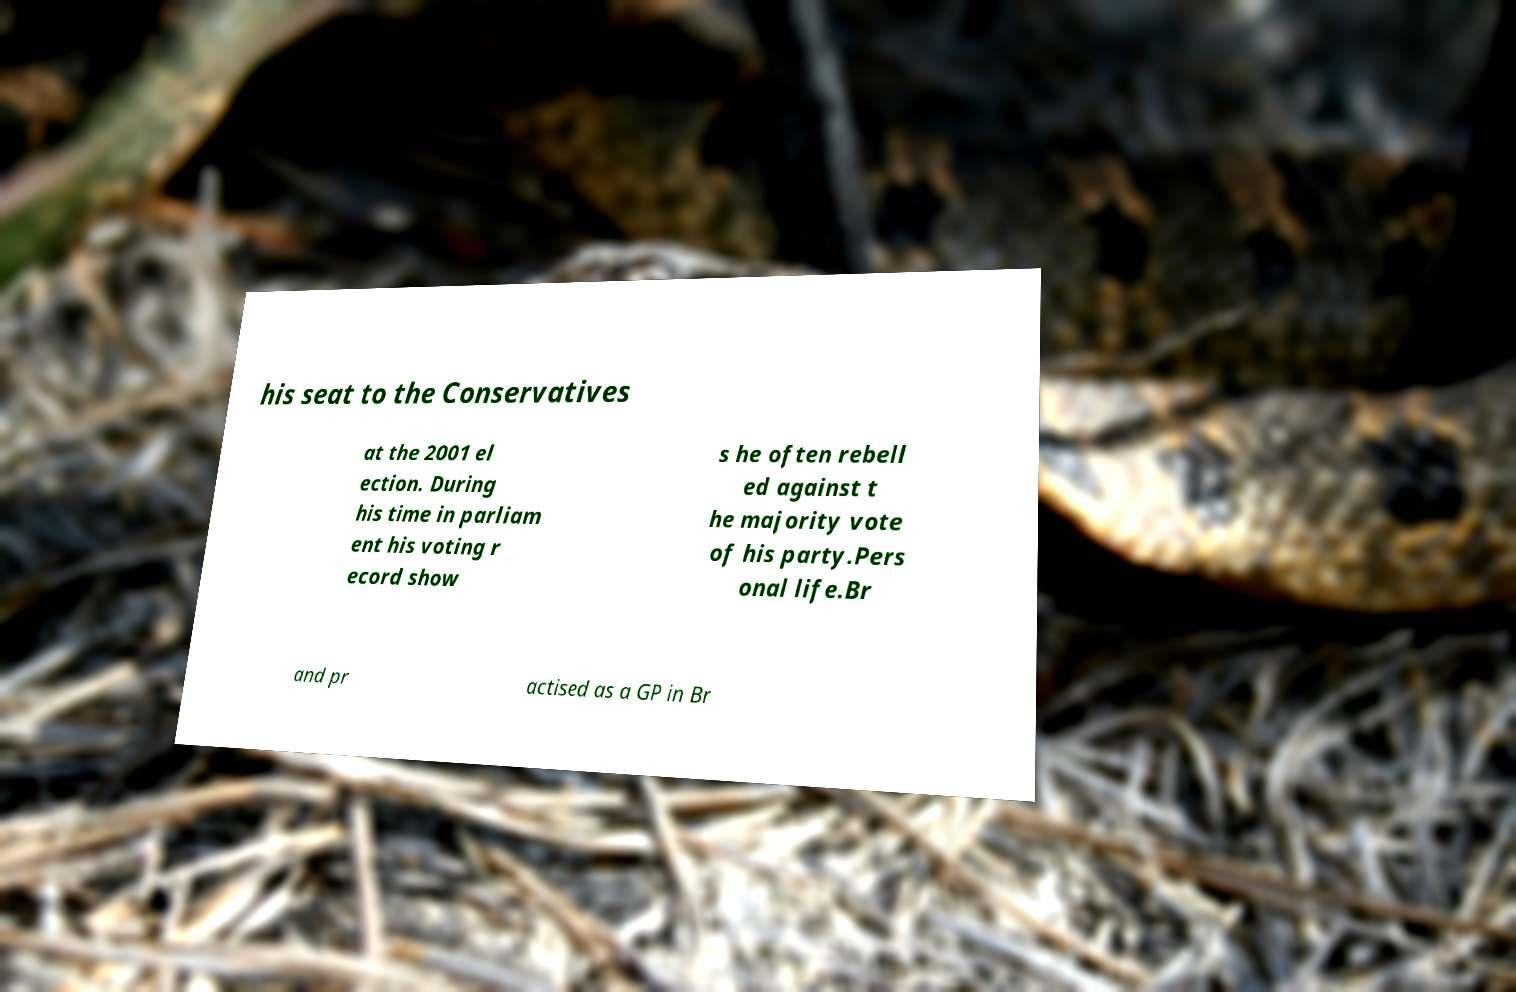Could you assist in decoding the text presented in this image and type it out clearly? his seat to the Conservatives at the 2001 el ection. During his time in parliam ent his voting r ecord show s he often rebell ed against t he majority vote of his party.Pers onal life.Br and pr actised as a GP in Br 